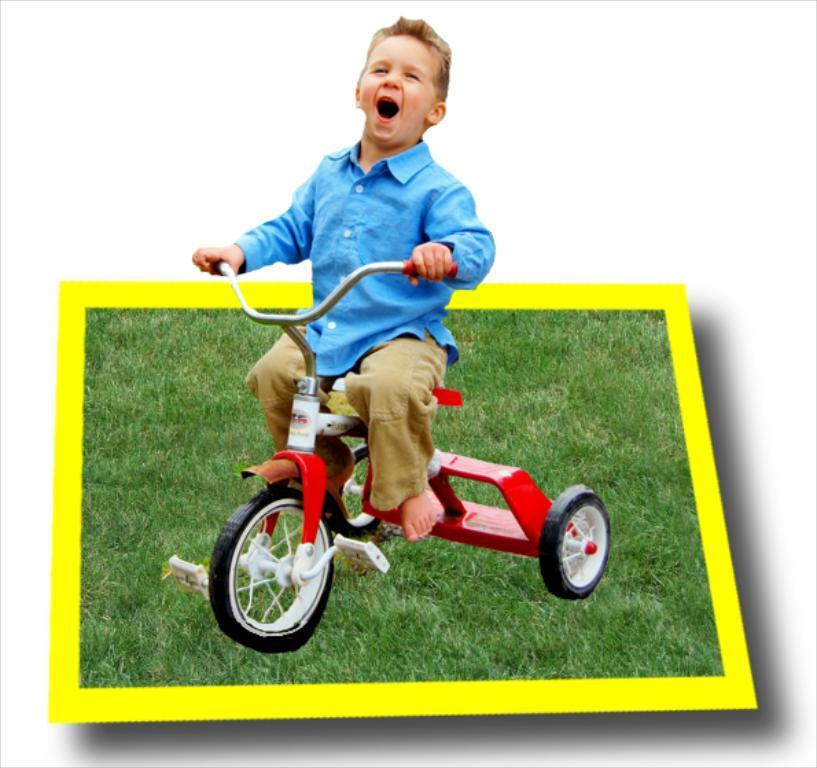How would you summarize this image in a sentence or two? In this image we can see an animated image which includes one boy sitting on the bicycle and we can see the grass. 